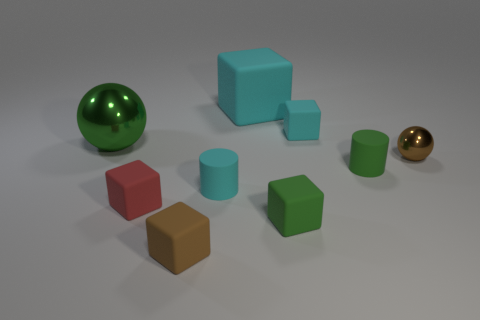There is a tiny cylinder that is the same color as the big sphere; what material is it?
Keep it short and to the point. Rubber. Does the brown object behind the brown rubber cube have the same shape as the tiny cyan rubber thing behind the small brown ball?
Provide a succinct answer. No. The object that is to the right of the big cyan matte thing and behind the big shiny object is what color?
Your response must be concise. Cyan. There is a tiny metal thing; is it the same color as the metallic thing that is to the left of the tiny sphere?
Keep it short and to the point. No. What is the size of the thing that is on the left side of the small brown matte block and in front of the brown ball?
Provide a short and direct response. Small. How many other things are the same color as the big metal ball?
Make the answer very short. 2. What is the size of the shiny object that is right of the big ball to the left of the brown thing left of the small cyan block?
Provide a short and direct response. Small. There is a tiny cyan matte block; are there any cyan cylinders behind it?
Provide a short and direct response. No. Does the red matte thing have the same size as the cyan cylinder that is left of the green block?
Offer a terse response. Yes. How many other objects are there of the same material as the big green ball?
Offer a terse response. 1. 